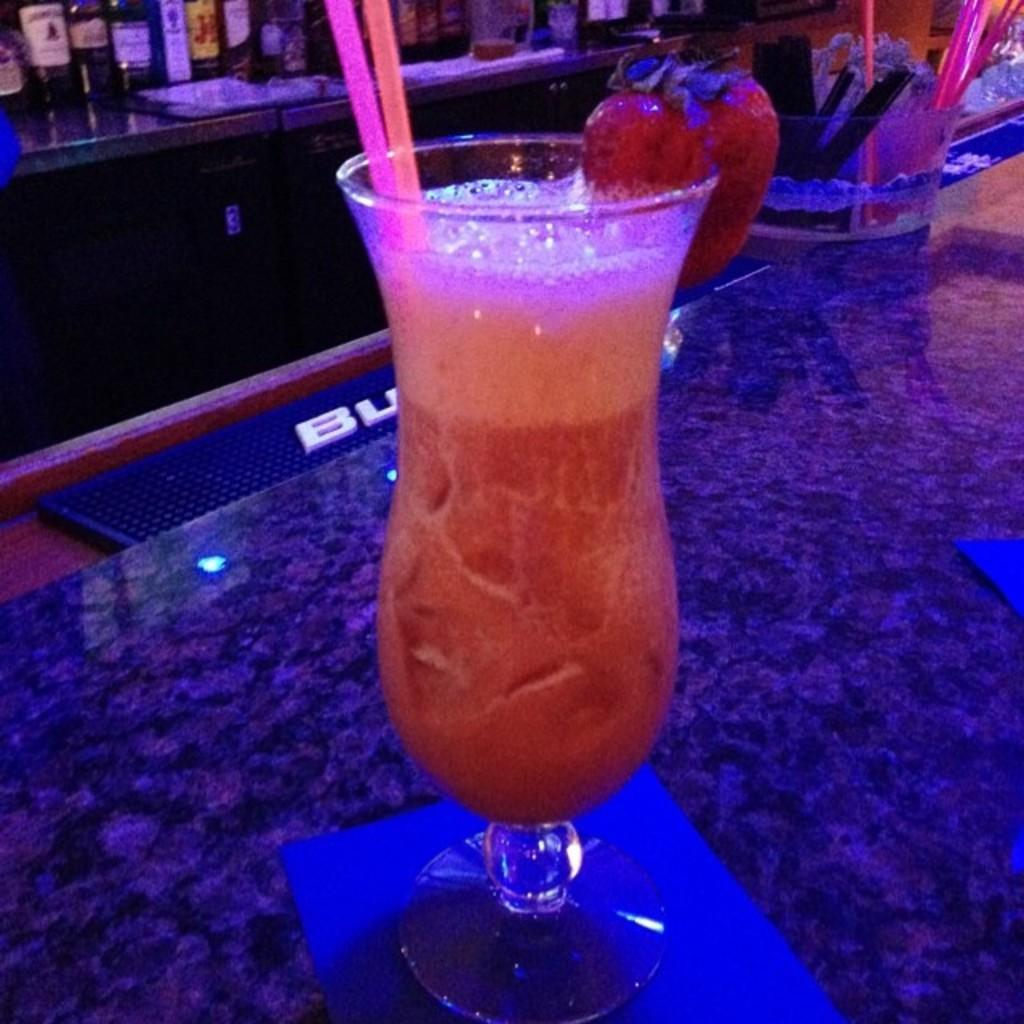What is the main piece of furniture in the image? There is a table in the image. What is on the table? There is a glass on the table. What is inside the glass? The glass contains juice. Can you describe the background of the image? There is another table in the background with bottles on it. What type of muscle is being exercised by the carpenter in the image? There is no carpenter or muscle activity present in the image. How many bricks are visible on the table in the image? There are no bricks visible in the image; it features a table with a glass of juice and a background table with bottles. 